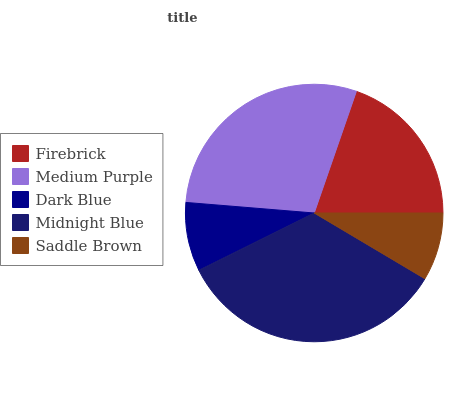Is Saddle Brown the minimum?
Answer yes or no. Yes. Is Midnight Blue the maximum?
Answer yes or no. Yes. Is Medium Purple the minimum?
Answer yes or no. No. Is Medium Purple the maximum?
Answer yes or no. No. Is Medium Purple greater than Firebrick?
Answer yes or no. Yes. Is Firebrick less than Medium Purple?
Answer yes or no. Yes. Is Firebrick greater than Medium Purple?
Answer yes or no. No. Is Medium Purple less than Firebrick?
Answer yes or no. No. Is Firebrick the high median?
Answer yes or no. Yes. Is Firebrick the low median?
Answer yes or no. Yes. Is Midnight Blue the high median?
Answer yes or no. No. Is Midnight Blue the low median?
Answer yes or no. No. 